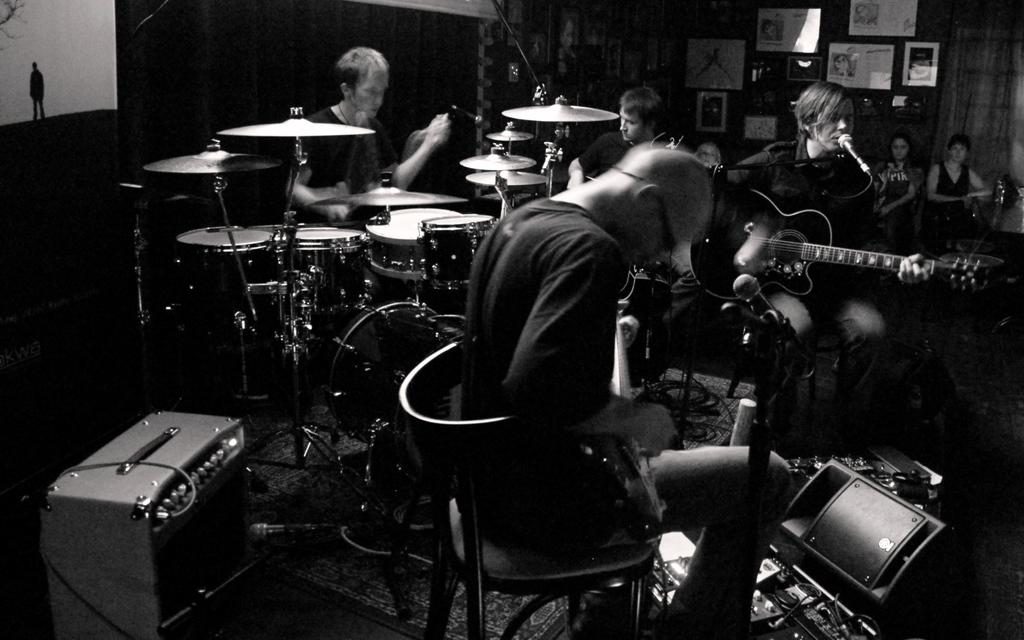How many people are playing musical instruments in the image? There are four men in the image, and they are playing drums, guitar, and singing on a mic. What are the other two people in the image doing? There are two persons in the background looking at the musicians. What can be seen on the wall in the background? There is a wall with frames in the background. What is the weight of the fact that the snow is falling in the image? There is no mention of snow in the image, so it cannot be determined if it is falling or if there is any weight associated with it. 